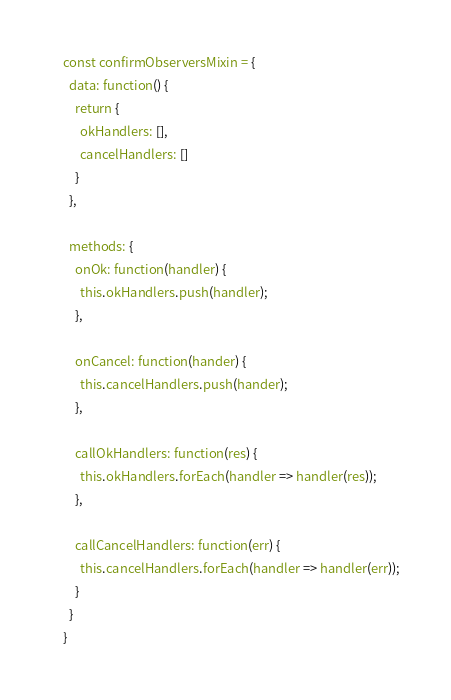Convert code to text. <code><loc_0><loc_0><loc_500><loc_500><_JavaScript_>const confirmObserversMixin = {
  data: function() {
    return {
      okHandlers: [],
      cancelHandlers: []
    }
  },

  methods: {
    onOk: function(handler) {
      this.okHandlers.push(handler);
    },

    onCancel: function(hander) {
      this.cancelHandlers.push(hander);
    },

    callOkHandlers: function(res) {
      this.okHandlers.forEach(handler => handler(res));
    },

    callCancelHandlers: function(err) {
      this.cancelHandlers.forEach(handler => handler(err));
    }
  }
}</code> 